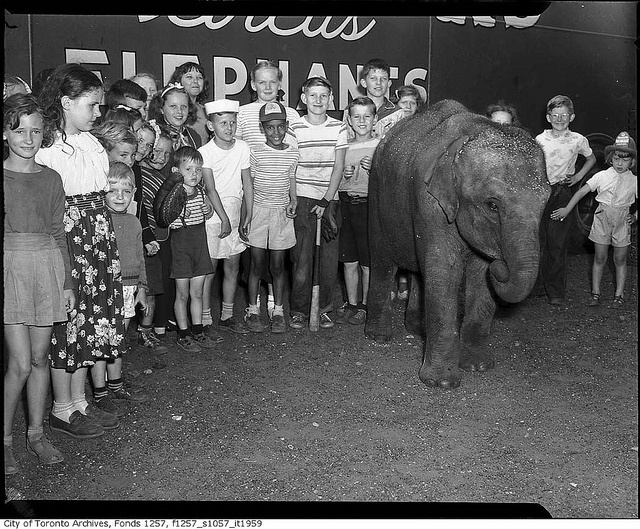Describe the objects in this image and their specific colors. I can see elephant in black, gray, and lightgray tones, people in black, gray, darkgray, and lightgray tones, people in black, lightgray, gray, and darkgray tones, people in black, darkgray, gray, and lightgray tones, and people in black, darkgray, gray, and lightgray tones in this image. 